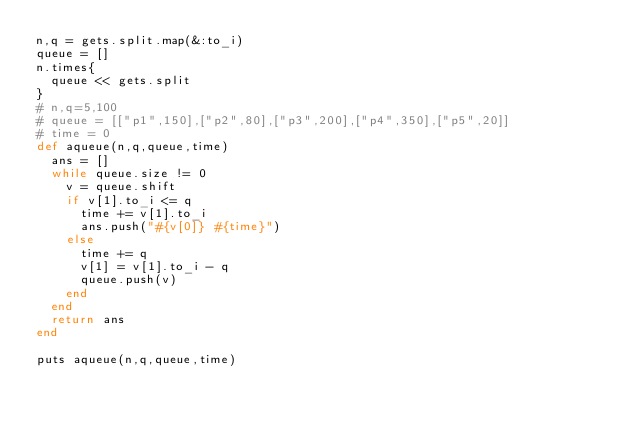Convert code to text. <code><loc_0><loc_0><loc_500><loc_500><_Ruby_>n,q = gets.split.map(&:to_i)
queue = []
n.times{
  queue << gets.split
}
# n,q=5,100
# queue = [["p1",150],["p2",80],["p3",200],["p4",350],["p5",20]]
# time = 0
def aqueue(n,q,queue,time)
  ans = []
  while queue.size != 0
    v = queue.shift
    if v[1].to_i <= q
      time += v[1].to_i
      ans.push("#{v[0]} #{time}")
    else
      time += q
      v[1] = v[1].to_i - q
      queue.push(v)
    end
  end
  return ans
end

puts aqueue(n,q,queue,time)</code> 